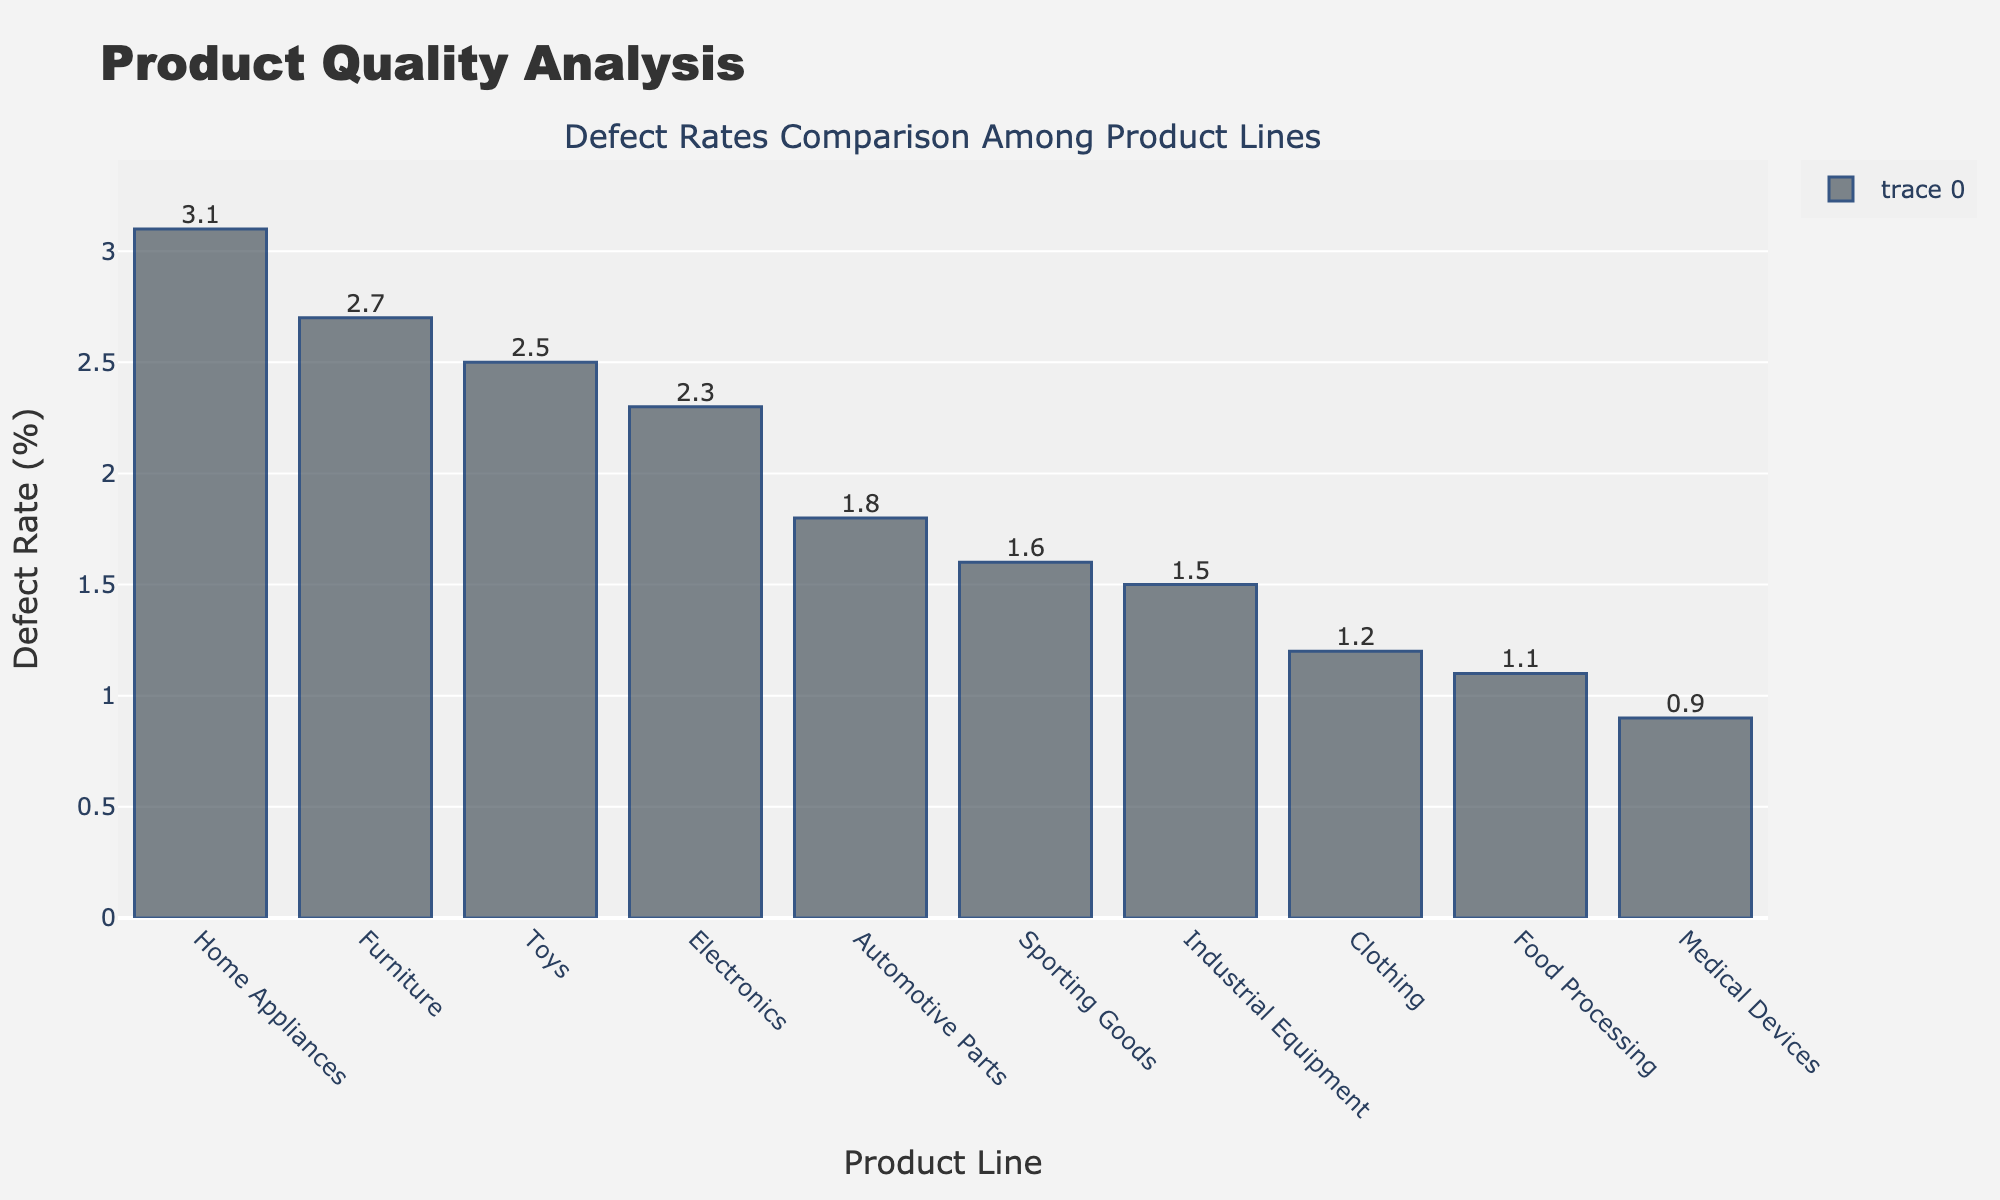Which product line has the highest defect rate? The bar with the highest height in the chart represents the product line with the highest defect rate. The Home Appliances bar is the tallest.
Answer: Home Appliances Which product line has the lowest defect rate? The shortest bar in the chart indicates the product line with the lowest defect rate. The Medical Devices bar is the shortest.
Answer: Medical Devices Compare the defect rates of Electronics and Automotive Parts. Which one has a higher defect rate and by how much? The height of the Electronics bar is 2.3% and the Automotive Parts bar is 1.8%. Subtracting these values gives the difference.
Answer: Electronics has a higher defect rate by 0.5% What is the average defect rate of the top 5 product lines with the highest defect rates? Identify the top 5 product lines from the chart: Home Appliances (3.1%), Furniture (2.7%), Toys (2.5%), Electronics (2.3%), and Automotive Parts (1.8%). Calculate the average: (3.1 + 2.7 + 2.5 + 2.3 + 1.8) / 5.
Answer: 2.48% How much higher is the defect rate of Home Appliances compared to Furniture? Identify the defect rates: Home Appliances (3.1%) and Furniture (2.7%). Subtract the Furniture rate from the Home Appliances rate.
Answer: 0.4% Which product lines have a defect rate less than 2%? Look for bars with heights representing defect rates under 2%. These product lines are Automotive Parts (1.8%), Industrial Equipment (1.5%), Clothing (1.2%), and Food Processing (1.1%).
Answer: Automotive Parts, Industrial Equipment, Clothing, Food Processing Between Sporting Goods and Medical Devices, which one has a lower defect rate and by how much? Identify the defect rates: Sporting Goods (1.6%) and Medical Devices (0.9%). Subtract the Medical Devices rate from the Sporting Goods rate.
Answer: Medical Devices, by 0.7% What is the total defect rate for Home Appliances and Toys combined? Add the defect rates of Home Appliances (3.1%) and Toys (2.5%).
Answer: 5.6% Rank the product lines from highest to lowest defect rate. Identify the heights of the bars and arrange them in descending order.
Answer: Home Appliances, Furniture, Toys, Electronics, Automotive Parts, Sporting Goods, Industrial Equipment, Clothing, Food Processing, Medical Devices Which product line has a defect rate closest to 2%? Identify the product lines with defect rates around 2% and choose the one closest to this value. The options near 2% are Electronics (2.3%) and Automotive Parts (1.8%). 2.3% is closer to 2%.
Answer: Electronics 